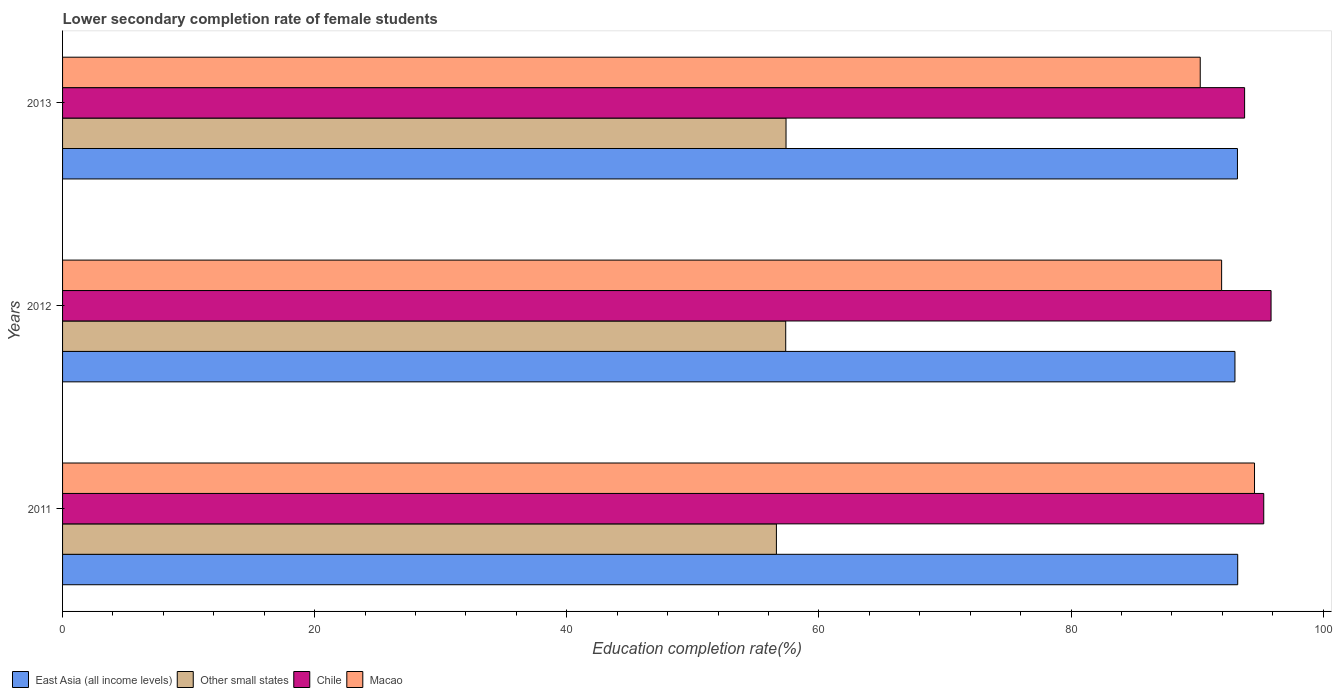How many groups of bars are there?
Ensure brevity in your answer.  3. Are the number of bars per tick equal to the number of legend labels?
Provide a short and direct response. Yes. Are the number of bars on each tick of the Y-axis equal?
Your response must be concise. Yes. How many bars are there on the 1st tick from the top?
Make the answer very short. 4. In how many cases, is the number of bars for a given year not equal to the number of legend labels?
Provide a succinct answer. 0. What is the lower secondary completion rate of female students in Chile in 2013?
Your answer should be compact. 93.77. Across all years, what is the maximum lower secondary completion rate of female students in East Asia (all income levels)?
Provide a succinct answer. 93.22. Across all years, what is the minimum lower secondary completion rate of female students in East Asia (all income levels)?
Offer a very short reply. 93. In which year was the lower secondary completion rate of female students in Macao maximum?
Your answer should be compact. 2011. What is the total lower secondary completion rate of female students in Macao in the graph?
Ensure brevity in your answer.  276.74. What is the difference between the lower secondary completion rate of female students in Other small states in 2011 and that in 2013?
Offer a very short reply. -0.76. What is the difference between the lower secondary completion rate of female students in Other small states in 2011 and the lower secondary completion rate of female students in Macao in 2013?
Your answer should be very brief. -33.62. What is the average lower secondary completion rate of female students in Macao per year?
Offer a very short reply. 92.25. In the year 2013, what is the difference between the lower secondary completion rate of female students in East Asia (all income levels) and lower secondary completion rate of female students in Other small states?
Provide a succinct answer. 35.81. In how many years, is the lower secondary completion rate of female students in East Asia (all income levels) greater than 76 %?
Your response must be concise. 3. What is the ratio of the lower secondary completion rate of female students in Macao in 2011 to that in 2012?
Offer a terse response. 1.03. What is the difference between the highest and the second highest lower secondary completion rate of female students in East Asia (all income levels)?
Your response must be concise. 0.02. What is the difference between the highest and the lowest lower secondary completion rate of female students in Chile?
Provide a short and direct response. 2.1. In how many years, is the lower secondary completion rate of female students in Chile greater than the average lower secondary completion rate of female students in Chile taken over all years?
Your answer should be very brief. 2. Is it the case that in every year, the sum of the lower secondary completion rate of female students in Chile and lower secondary completion rate of female students in East Asia (all income levels) is greater than the sum of lower secondary completion rate of female students in Macao and lower secondary completion rate of female students in Other small states?
Offer a very short reply. Yes. What does the 4th bar from the top in 2011 represents?
Provide a short and direct response. East Asia (all income levels). What does the 2nd bar from the bottom in 2012 represents?
Your answer should be very brief. Other small states. How many bars are there?
Make the answer very short. 12. How many years are there in the graph?
Keep it short and to the point. 3. Are the values on the major ticks of X-axis written in scientific E-notation?
Make the answer very short. No. Does the graph contain grids?
Provide a succinct answer. No. How are the legend labels stacked?
Your response must be concise. Horizontal. What is the title of the graph?
Provide a short and direct response. Lower secondary completion rate of female students. What is the label or title of the X-axis?
Your response must be concise. Education completion rate(%). What is the label or title of the Y-axis?
Ensure brevity in your answer.  Years. What is the Education completion rate(%) of East Asia (all income levels) in 2011?
Make the answer very short. 93.22. What is the Education completion rate(%) of Other small states in 2011?
Keep it short and to the point. 56.63. What is the Education completion rate(%) of Chile in 2011?
Make the answer very short. 95.28. What is the Education completion rate(%) in Macao in 2011?
Give a very brief answer. 94.55. What is the Education completion rate(%) in East Asia (all income levels) in 2012?
Make the answer very short. 93. What is the Education completion rate(%) in Other small states in 2012?
Make the answer very short. 57.36. What is the Education completion rate(%) of Chile in 2012?
Offer a terse response. 95.87. What is the Education completion rate(%) in Macao in 2012?
Your answer should be very brief. 91.94. What is the Education completion rate(%) in East Asia (all income levels) in 2013?
Keep it short and to the point. 93.2. What is the Education completion rate(%) of Other small states in 2013?
Your response must be concise. 57.39. What is the Education completion rate(%) of Chile in 2013?
Your response must be concise. 93.77. What is the Education completion rate(%) in Macao in 2013?
Make the answer very short. 90.25. Across all years, what is the maximum Education completion rate(%) in East Asia (all income levels)?
Make the answer very short. 93.22. Across all years, what is the maximum Education completion rate(%) in Other small states?
Your response must be concise. 57.39. Across all years, what is the maximum Education completion rate(%) in Chile?
Offer a terse response. 95.87. Across all years, what is the maximum Education completion rate(%) of Macao?
Your answer should be very brief. 94.55. Across all years, what is the minimum Education completion rate(%) of East Asia (all income levels)?
Offer a terse response. 93. Across all years, what is the minimum Education completion rate(%) in Other small states?
Your response must be concise. 56.63. Across all years, what is the minimum Education completion rate(%) of Chile?
Keep it short and to the point. 93.77. Across all years, what is the minimum Education completion rate(%) of Macao?
Offer a terse response. 90.25. What is the total Education completion rate(%) in East Asia (all income levels) in the graph?
Give a very brief answer. 279.42. What is the total Education completion rate(%) in Other small states in the graph?
Make the answer very short. 171.38. What is the total Education completion rate(%) of Chile in the graph?
Make the answer very short. 284.92. What is the total Education completion rate(%) in Macao in the graph?
Offer a very short reply. 276.74. What is the difference between the Education completion rate(%) in East Asia (all income levels) in 2011 and that in 2012?
Offer a very short reply. 0.22. What is the difference between the Education completion rate(%) in Other small states in 2011 and that in 2012?
Offer a terse response. -0.74. What is the difference between the Education completion rate(%) of Chile in 2011 and that in 2012?
Offer a terse response. -0.58. What is the difference between the Education completion rate(%) of Macao in 2011 and that in 2012?
Your answer should be compact. 2.61. What is the difference between the Education completion rate(%) in East Asia (all income levels) in 2011 and that in 2013?
Make the answer very short. 0.02. What is the difference between the Education completion rate(%) of Other small states in 2011 and that in 2013?
Keep it short and to the point. -0.76. What is the difference between the Education completion rate(%) in Chile in 2011 and that in 2013?
Your answer should be compact. 1.52. What is the difference between the Education completion rate(%) of Macao in 2011 and that in 2013?
Your answer should be very brief. 4.31. What is the difference between the Education completion rate(%) in East Asia (all income levels) in 2012 and that in 2013?
Offer a very short reply. -0.2. What is the difference between the Education completion rate(%) of Other small states in 2012 and that in 2013?
Your response must be concise. -0.02. What is the difference between the Education completion rate(%) in Chile in 2012 and that in 2013?
Keep it short and to the point. 2.1. What is the difference between the Education completion rate(%) of Macao in 2012 and that in 2013?
Your answer should be very brief. 1.7. What is the difference between the Education completion rate(%) in East Asia (all income levels) in 2011 and the Education completion rate(%) in Other small states in 2012?
Offer a terse response. 35.85. What is the difference between the Education completion rate(%) of East Asia (all income levels) in 2011 and the Education completion rate(%) of Chile in 2012?
Your answer should be compact. -2.65. What is the difference between the Education completion rate(%) of East Asia (all income levels) in 2011 and the Education completion rate(%) of Macao in 2012?
Your response must be concise. 1.28. What is the difference between the Education completion rate(%) in Other small states in 2011 and the Education completion rate(%) in Chile in 2012?
Keep it short and to the point. -39.24. What is the difference between the Education completion rate(%) in Other small states in 2011 and the Education completion rate(%) in Macao in 2012?
Make the answer very short. -35.32. What is the difference between the Education completion rate(%) of Chile in 2011 and the Education completion rate(%) of Macao in 2012?
Offer a very short reply. 3.34. What is the difference between the Education completion rate(%) in East Asia (all income levels) in 2011 and the Education completion rate(%) in Other small states in 2013?
Provide a short and direct response. 35.83. What is the difference between the Education completion rate(%) of East Asia (all income levels) in 2011 and the Education completion rate(%) of Chile in 2013?
Your answer should be compact. -0.55. What is the difference between the Education completion rate(%) of East Asia (all income levels) in 2011 and the Education completion rate(%) of Macao in 2013?
Ensure brevity in your answer.  2.97. What is the difference between the Education completion rate(%) in Other small states in 2011 and the Education completion rate(%) in Chile in 2013?
Offer a very short reply. -37.14. What is the difference between the Education completion rate(%) in Other small states in 2011 and the Education completion rate(%) in Macao in 2013?
Provide a short and direct response. -33.62. What is the difference between the Education completion rate(%) in Chile in 2011 and the Education completion rate(%) in Macao in 2013?
Provide a short and direct response. 5.04. What is the difference between the Education completion rate(%) of East Asia (all income levels) in 2012 and the Education completion rate(%) of Other small states in 2013?
Give a very brief answer. 35.61. What is the difference between the Education completion rate(%) in East Asia (all income levels) in 2012 and the Education completion rate(%) in Chile in 2013?
Keep it short and to the point. -0.77. What is the difference between the Education completion rate(%) in East Asia (all income levels) in 2012 and the Education completion rate(%) in Macao in 2013?
Make the answer very short. 2.75. What is the difference between the Education completion rate(%) of Other small states in 2012 and the Education completion rate(%) of Chile in 2013?
Your answer should be very brief. -36.4. What is the difference between the Education completion rate(%) in Other small states in 2012 and the Education completion rate(%) in Macao in 2013?
Provide a succinct answer. -32.88. What is the difference between the Education completion rate(%) of Chile in 2012 and the Education completion rate(%) of Macao in 2013?
Provide a short and direct response. 5.62. What is the average Education completion rate(%) of East Asia (all income levels) per year?
Give a very brief answer. 93.14. What is the average Education completion rate(%) in Other small states per year?
Provide a succinct answer. 57.13. What is the average Education completion rate(%) in Chile per year?
Give a very brief answer. 94.97. What is the average Education completion rate(%) of Macao per year?
Ensure brevity in your answer.  92.25. In the year 2011, what is the difference between the Education completion rate(%) of East Asia (all income levels) and Education completion rate(%) of Other small states?
Give a very brief answer. 36.59. In the year 2011, what is the difference between the Education completion rate(%) of East Asia (all income levels) and Education completion rate(%) of Chile?
Provide a succinct answer. -2.07. In the year 2011, what is the difference between the Education completion rate(%) of East Asia (all income levels) and Education completion rate(%) of Macao?
Provide a succinct answer. -1.33. In the year 2011, what is the difference between the Education completion rate(%) of Other small states and Education completion rate(%) of Chile?
Provide a succinct answer. -38.66. In the year 2011, what is the difference between the Education completion rate(%) of Other small states and Education completion rate(%) of Macao?
Your answer should be very brief. -37.93. In the year 2011, what is the difference between the Education completion rate(%) of Chile and Education completion rate(%) of Macao?
Your answer should be very brief. 0.73. In the year 2012, what is the difference between the Education completion rate(%) of East Asia (all income levels) and Education completion rate(%) of Other small states?
Keep it short and to the point. 35.64. In the year 2012, what is the difference between the Education completion rate(%) in East Asia (all income levels) and Education completion rate(%) in Chile?
Keep it short and to the point. -2.87. In the year 2012, what is the difference between the Education completion rate(%) in East Asia (all income levels) and Education completion rate(%) in Macao?
Ensure brevity in your answer.  1.06. In the year 2012, what is the difference between the Education completion rate(%) of Other small states and Education completion rate(%) of Chile?
Offer a terse response. -38.5. In the year 2012, what is the difference between the Education completion rate(%) in Other small states and Education completion rate(%) in Macao?
Offer a terse response. -34.58. In the year 2012, what is the difference between the Education completion rate(%) in Chile and Education completion rate(%) in Macao?
Keep it short and to the point. 3.92. In the year 2013, what is the difference between the Education completion rate(%) in East Asia (all income levels) and Education completion rate(%) in Other small states?
Ensure brevity in your answer.  35.81. In the year 2013, what is the difference between the Education completion rate(%) in East Asia (all income levels) and Education completion rate(%) in Chile?
Offer a very short reply. -0.57. In the year 2013, what is the difference between the Education completion rate(%) in East Asia (all income levels) and Education completion rate(%) in Macao?
Offer a very short reply. 2.95. In the year 2013, what is the difference between the Education completion rate(%) of Other small states and Education completion rate(%) of Chile?
Offer a terse response. -36.38. In the year 2013, what is the difference between the Education completion rate(%) in Other small states and Education completion rate(%) in Macao?
Offer a terse response. -32.86. In the year 2013, what is the difference between the Education completion rate(%) of Chile and Education completion rate(%) of Macao?
Give a very brief answer. 3.52. What is the ratio of the Education completion rate(%) of Other small states in 2011 to that in 2012?
Offer a terse response. 0.99. What is the ratio of the Education completion rate(%) in Chile in 2011 to that in 2012?
Give a very brief answer. 0.99. What is the ratio of the Education completion rate(%) in Macao in 2011 to that in 2012?
Provide a short and direct response. 1.03. What is the ratio of the Education completion rate(%) of Other small states in 2011 to that in 2013?
Offer a very short reply. 0.99. What is the ratio of the Education completion rate(%) in Chile in 2011 to that in 2013?
Ensure brevity in your answer.  1.02. What is the ratio of the Education completion rate(%) of Macao in 2011 to that in 2013?
Offer a very short reply. 1.05. What is the ratio of the Education completion rate(%) in Chile in 2012 to that in 2013?
Keep it short and to the point. 1.02. What is the ratio of the Education completion rate(%) of Macao in 2012 to that in 2013?
Ensure brevity in your answer.  1.02. What is the difference between the highest and the second highest Education completion rate(%) of East Asia (all income levels)?
Give a very brief answer. 0.02. What is the difference between the highest and the second highest Education completion rate(%) of Other small states?
Provide a short and direct response. 0.02. What is the difference between the highest and the second highest Education completion rate(%) of Chile?
Your response must be concise. 0.58. What is the difference between the highest and the second highest Education completion rate(%) in Macao?
Offer a terse response. 2.61. What is the difference between the highest and the lowest Education completion rate(%) in East Asia (all income levels)?
Offer a very short reply. 0.22. What is the difference between the highest and the lowest Education completion rate(%) of Other small states?
Offer a very short reply. 0.76. What is the difference between the highest and the lowest Education completion rate(%) in Chile?
Provide a succinct answer. 2.1. What is the difference between the highest and the lowest Education completion rate(%) of Macao?
Provide a short and direct response. 4.31. 